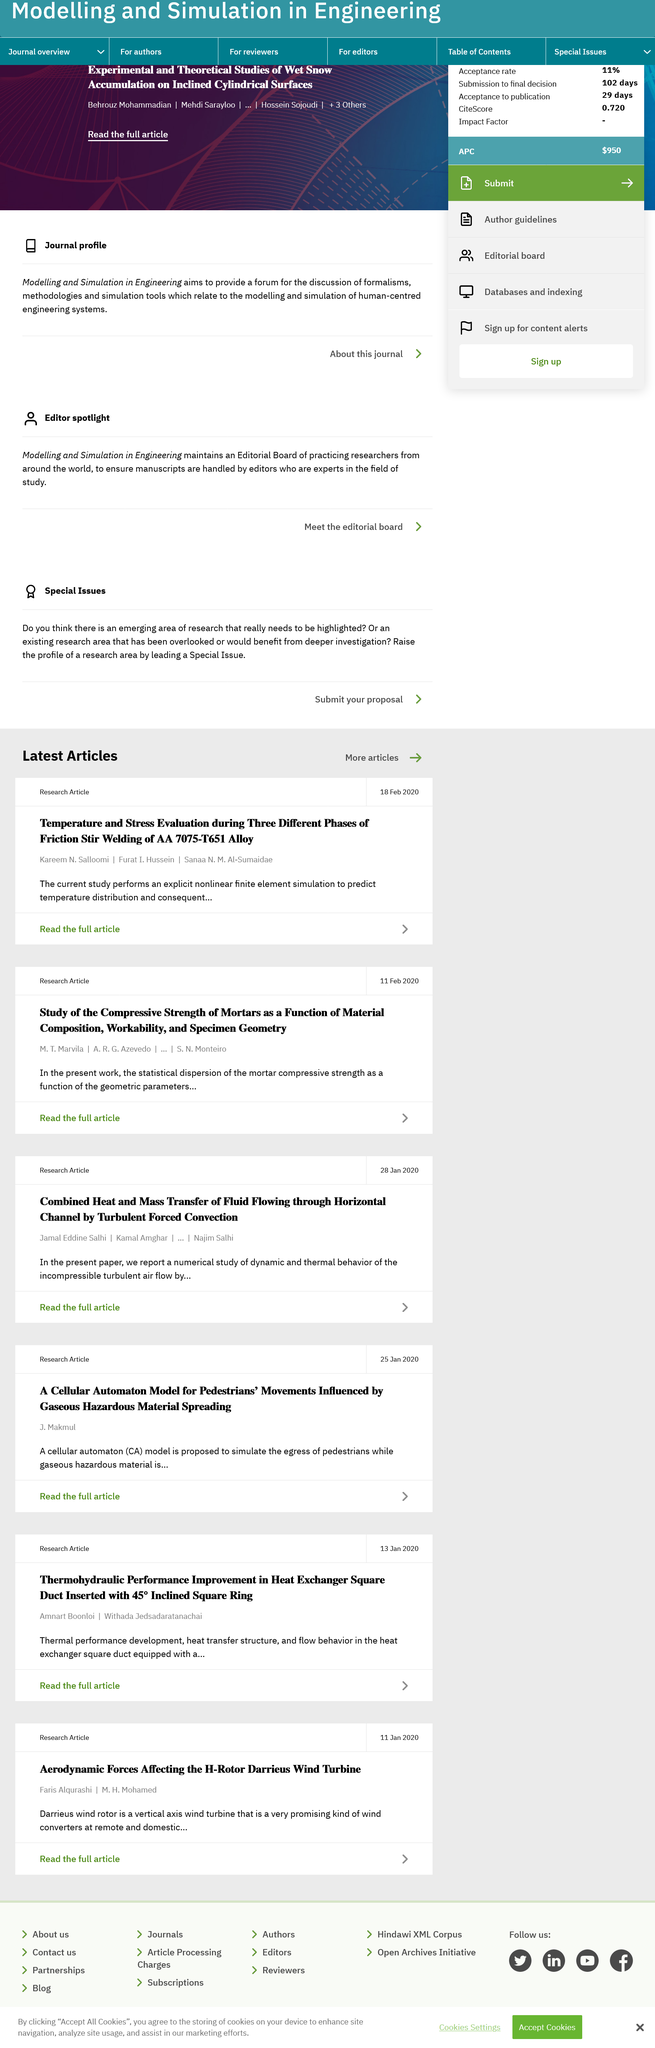Highlight a few significant elements in this photo. The second article was published on February 11, 2020. The authors of the papers shown are not all the same, as stated. The aims of both studies are not the same. 